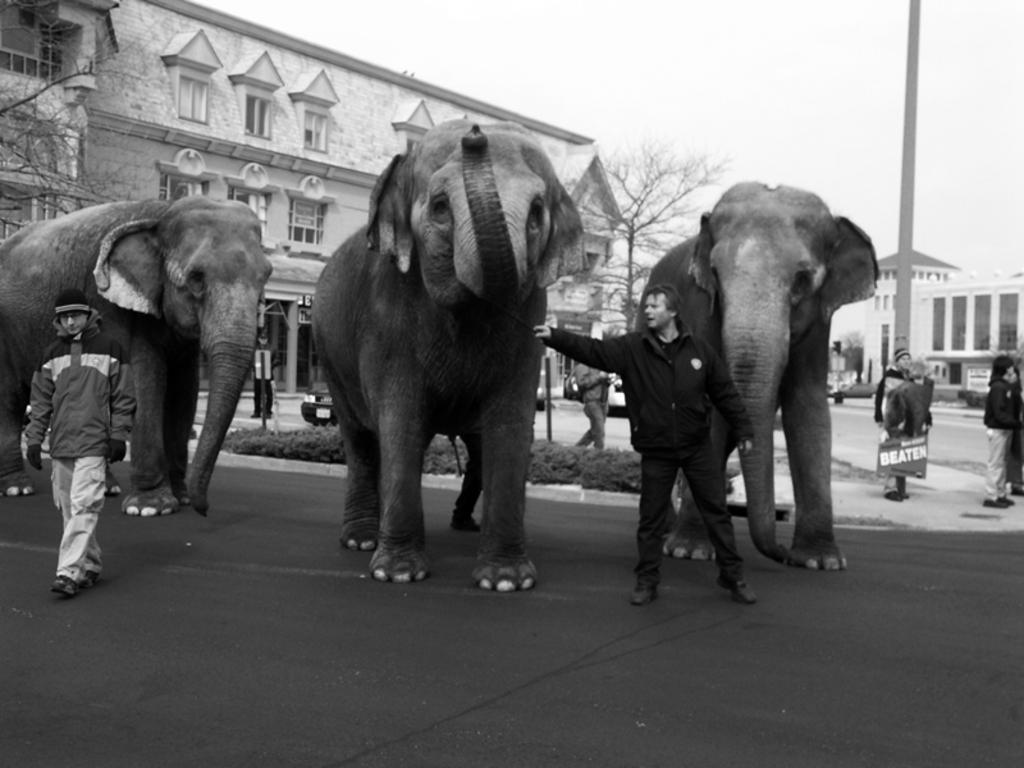Could you give a brief overview of what you see in this image? As we can see in the image there is a sky, building, dry tree and few people here and there and there are three elephants. 